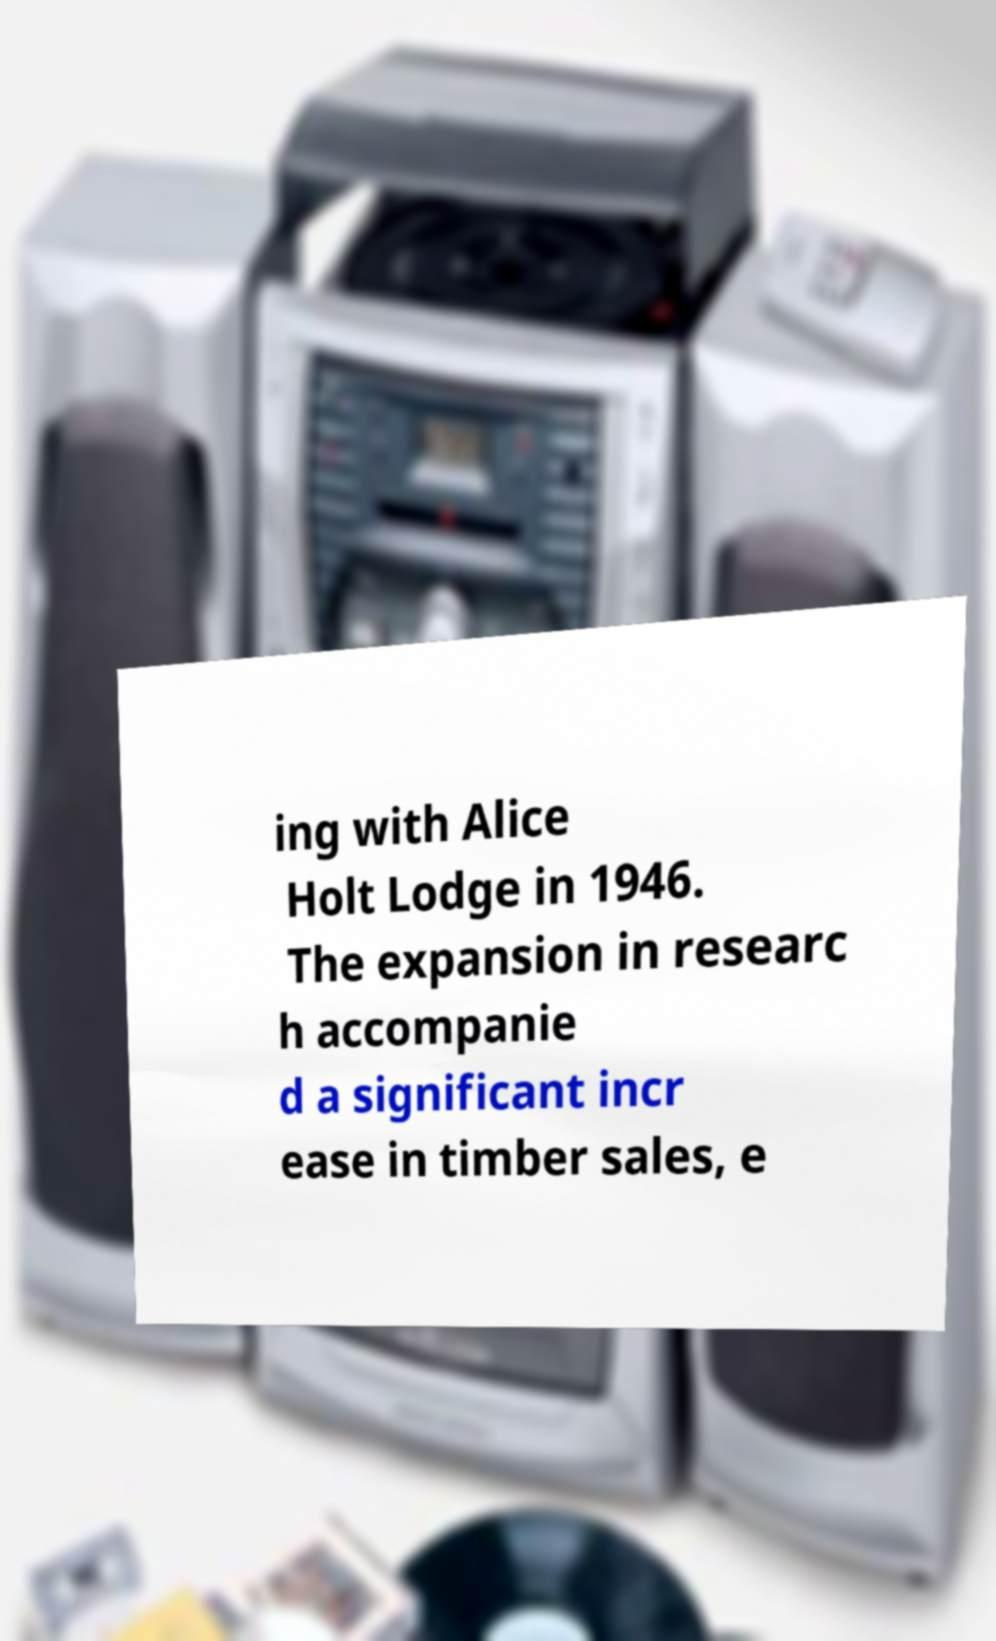Could you assist in decoding the text presented in this image and type it out clearly? ing with Alice Holt Lodge in 1946. The expansion in researc h accompanie d a significant incr ease in timber sales, e 